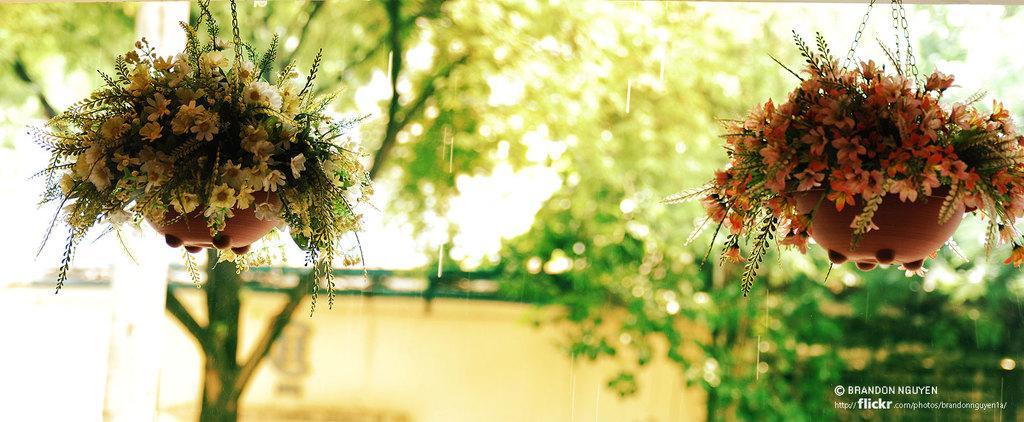Could you give a brief overview of what you see in this image? In this image we can see two hanging flower pots. In the background we can see the trees and also the wall. In the bottom right corner there is text. 